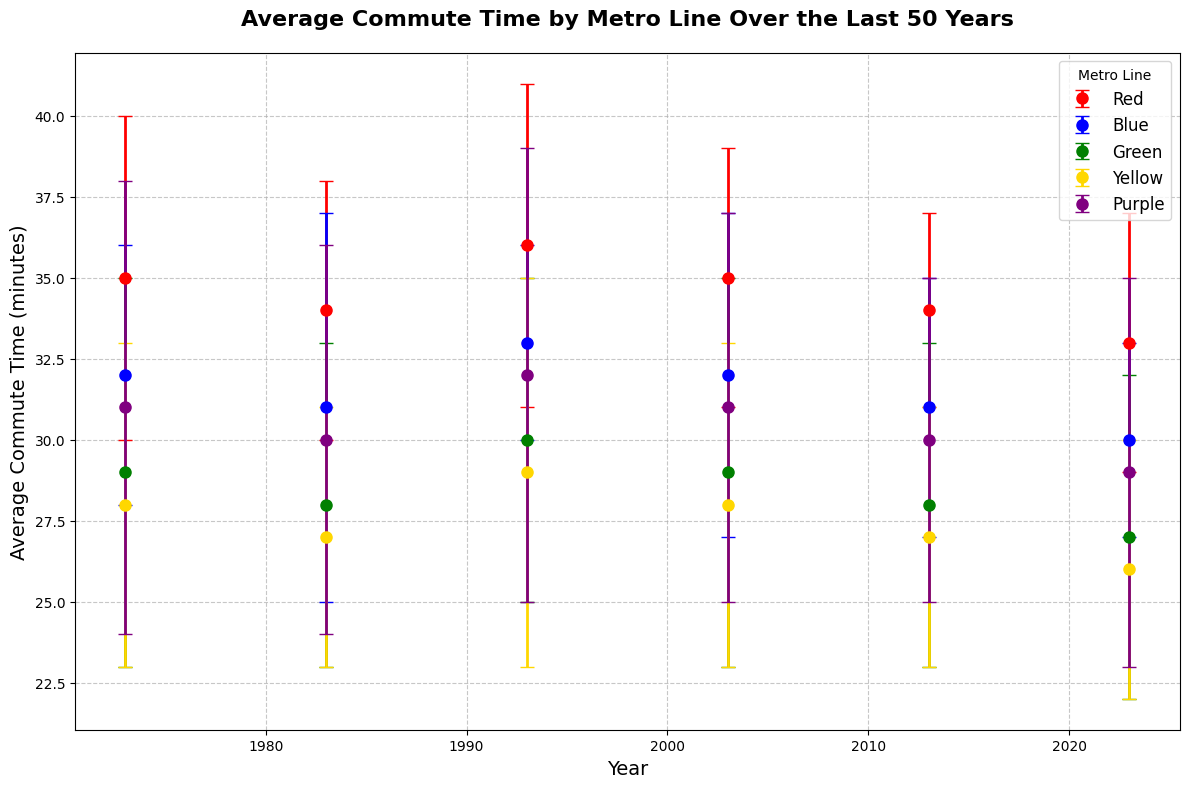How has the average commute time for the Red line changed over 50 years? To answer this question, look at the data points for the Red line across the years. In 1973, the commute time was 35 minutes, then decreased slightly to 34 minutes in 1983, increased to 36 minutes in 1993, back to 35 minutes in 2003, then decreased to 34 minutes in 2013, and finally to 33 minutes in 2023.
Answer: It decreased from 35 minutes to 33 minutes Which metro line had the highest average commute time in 1973 and which one had the lowest? In 1973, the highest average commute time was for the Red line at 35 minutes. The lowest was the Yellow line at 28 minutes.
Answer: Red had the highest, Yellow had the lowest Between which two consecutive decades did the Blue line see the largest decrease in commute time? Look at the data points for the Blue line. Compare the commute times between consecutive decades: 1973-1983 (32 to 31, -1), 1983-1993 (31 to 33, +2), 1993-2003 (33 to 32, -1), 2003-2013 (32 to 31, -1), 2013-2023 (31 to 30, -1). The largest decrease is between 1983 and 1993 where it actually increased by 2 minutes but the largest actual decrease is between multiple other periods, however comparatively, no significant single period is drastically different.
Answer: None significantly What is the average of all commute times for the Purple line over the years shown? To find the average, add up all the commute times for the Purple line and divide by the number of data points. The commute times are 31 (1973), 30 (1983), 32 (1993), 31 (2003), 30 (2013), and 29 (2023). So, the average is (31+30+32+31+30+29)/6 = 30.5.
Answer: 30.5 Which metro line had the smallest uncertainty in 1983 and what was its value? Check the uncertainty values for each line in 1983. The smallest uncertainty was for Yellow with 4 minutes.
Answer: Yellow with 4 minutes How did the average commute time of the Green line change from 2003 to 2023? In 2003, the average commute time for the Green line was 29 minutes. In 2023, it decreased to 27 minutes.
Answer: It decreased by 2 minutes Which metro line maintained a consistent average commute time across the years with the least variation? To determine this, assess the commute times for each line across the years and see which shows the least variation. The Green line has maintained commute times from 1973 to 2023 with values ranging between 27 to 30 minutes, which indicates the least variation.
Answer: Green line What is the combined uncertainty for the Blue line and Yellow line in the year 1993? The uncertainties for the Blue line and Yellow line in 1993 are 3 and 6, respectively. The combined uncertainty is 3 + 6 = 9.
Answer: 9 